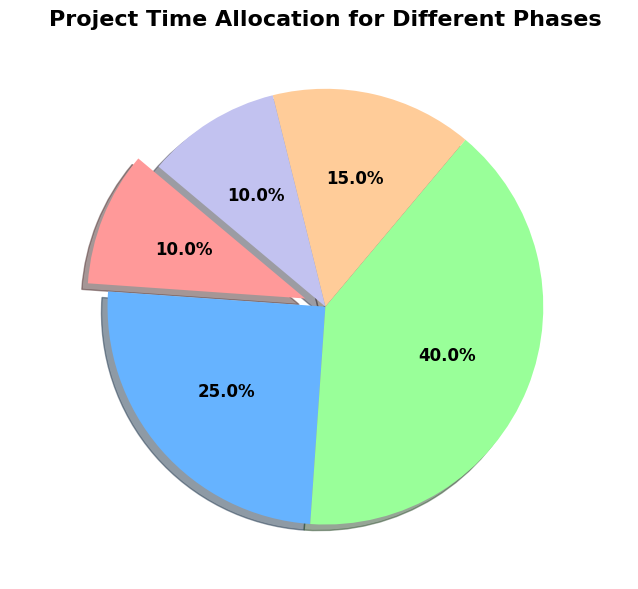What phase takes the most significant portion of the project time? Look at the pie chart segments' sizes; the largest segment represents the Execution phase.
Answer: Execution How much time do Initiation and Closing phases together take up? The Initiation phase takes up 10%, and the Closing phase takes up 10%. Added together: 10% + 10% = 20%.
Answer: 20% Which phase takes up more time, Planning or Monitoring? Compare the slices for Planning and Monitoring. Planning takes up 25%, and Monitoring takes up 15%.
Answer: Planning What is the difference in time allocation between Execution and Initiation phases? Execution is 40%, and Initiation is 10%. The difference is 40% - 10% = 30%.
Answer: 30% How many phases take up at least 15% of the project time? Check the segments that are 15% or larger: Planning (25%), Execution (40%), Monitoring (15%). There are three phases.
Answer: 3 Describe the color of the largest phase segment. Refer to the color of the largest segment, which is the Execution phase (green).
Answer: Green What is the average time allocation for the Planning, Execution, and Monitoring phases? Add the percentages: 25% (Planning) + 40% (Execution) + 15% (Monitoring) = 80%. Divide by 3: 80% / 3 ≈ 26.67%.
Answer: 26.67% Is the time allocation for the Execution phase more than double the time allocation for the Initiation phase? Execution is 40%, and Initiation is 10%. Double of Initiation is 10% * 2 = 20%. Since 40% is greater than 20%, yes.
Answer: Yes Which phase closely follows Execution in terms of time allocation? Identify the second-largest segment after Execution. Planning is 25%.
Answer: Planning 